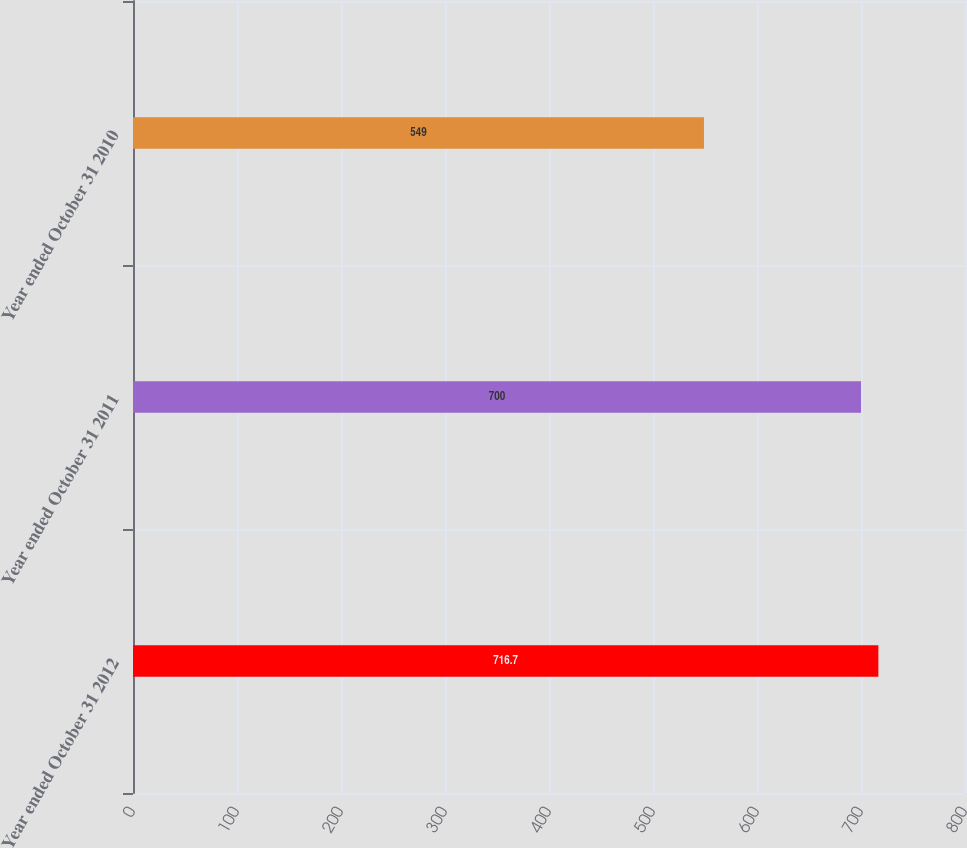<chart> <loc_0><loc_0><loc_500><loc_500><bar_chart><fcel>Year ended October 31 2012<fcel>Year ended October 31 2011<fcel>Year ended October 31 2010<nl><fcel>716.7<fcel>700<fcel>549<nl></chart> 